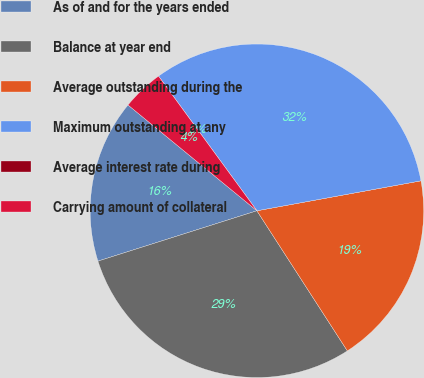Convert chart. <chart><loc_0><loc_0><loc_500><loc_500><pie_chart><fcel>As of and for the years ended<fcel>Balance at year end<fcel>Average outstanding during the<fcel>Maximum outstanding at any<fcel>Average interest rate during<fcel>Carrying amount of collateral<nl><fcel>15.82%<fcel>29.24%<fcel>18.75%<fcel>32.17%<fcel>0.0%<fcel>4.02%<nl></chart> 